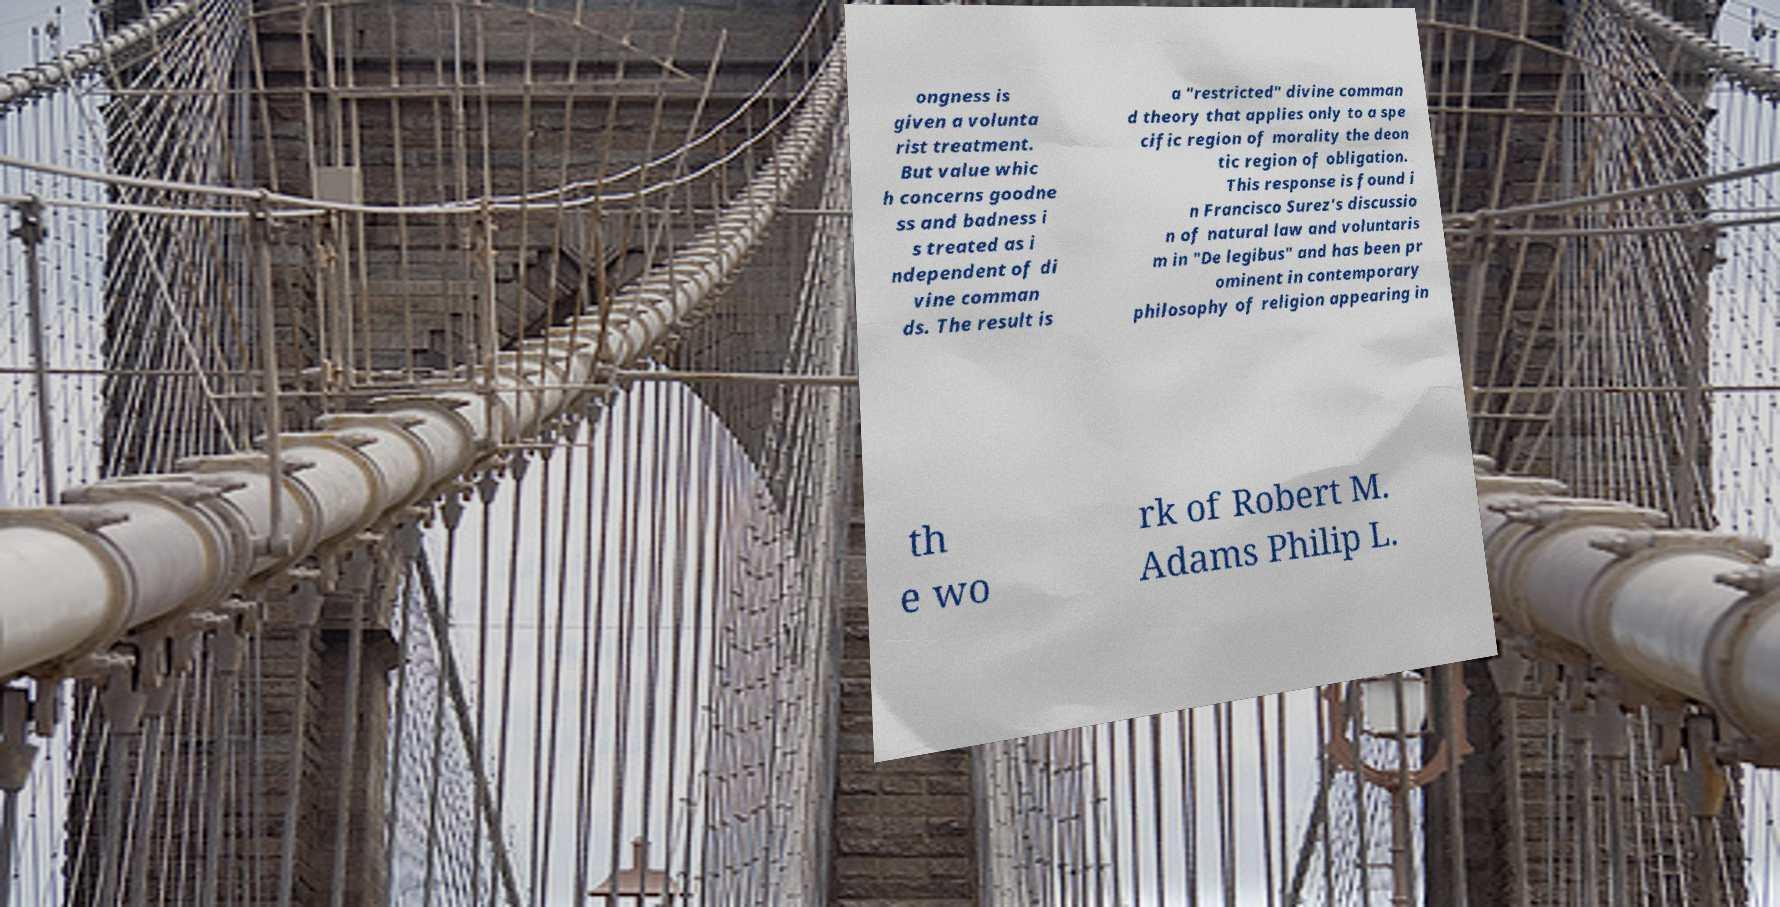What messages or text are displayed in this image? I need them in a readable, typed format. ongness is given a volunta rist treatment. But value whic h concerns goodne ss and badness i s treated as i ndependent of di vine comman ds. The result is a "restricted" divine comman d theory that applies only to a spe cific region of morality the deon tic region of obligation. This response is found i n Francisco Surez's discussio n of natural law and voluntaris m in "De legibus" and has been pr ominent in contemporary philosophy of religion appearing in th e wo rk of Robert M. Adams Philip L. 